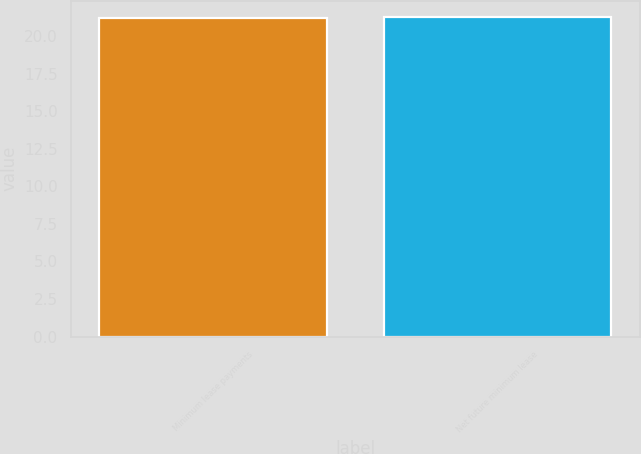Convert chart to OTSL. <chart><loc_0><loc_0><loc_500><loc_500><bar_chart><fcel>Minimum lease payments<fcel>Net future minimum lease<nl><fcel>21.2<fcel>21.3<nl></chart> 